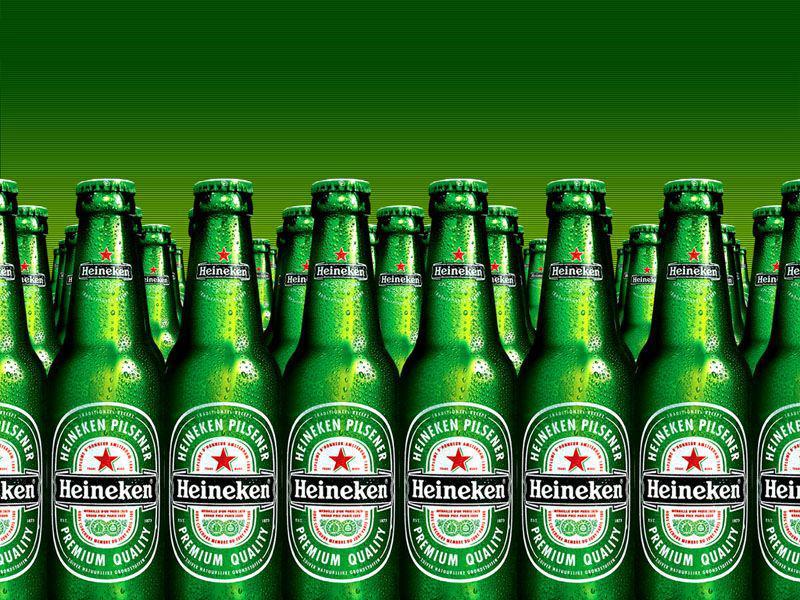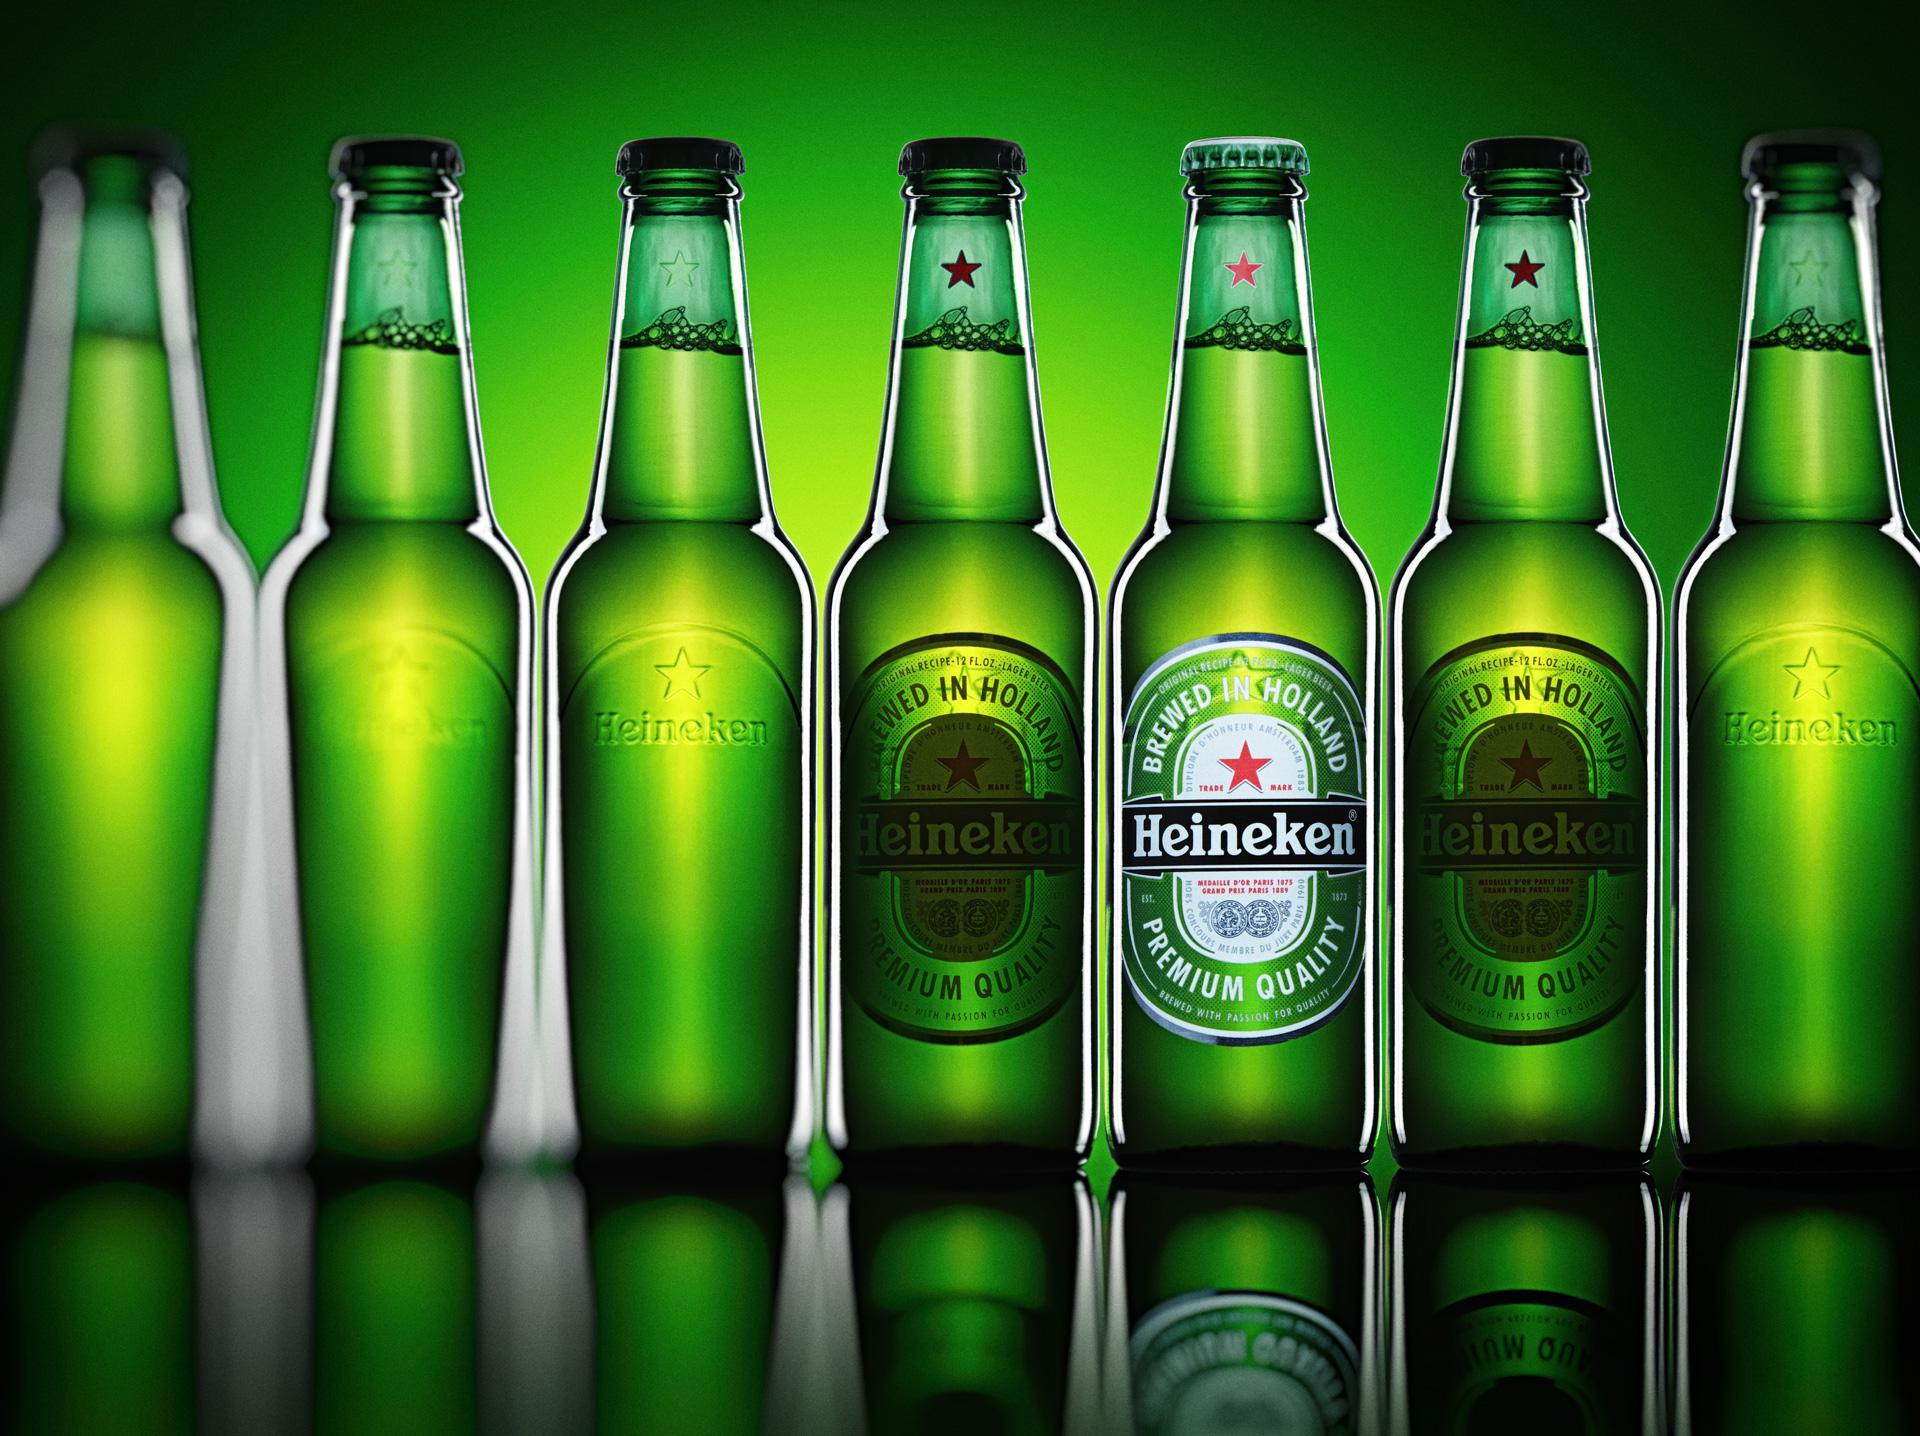The first image is the image on the left, the second image is the image on the right. Given the left and right images, does the statement "In at least one image there are six green beer bottles." hold true? Answer yes or no. No. The first image is the image on the left, the second image is the image on the right. Evaluate the accuracy of this statement regarding the images: "An image shows one stand-out bottle with its label clearly showing, amid at least a half dozen green bottles.". Is it true? Answer yes or no. Yes. 